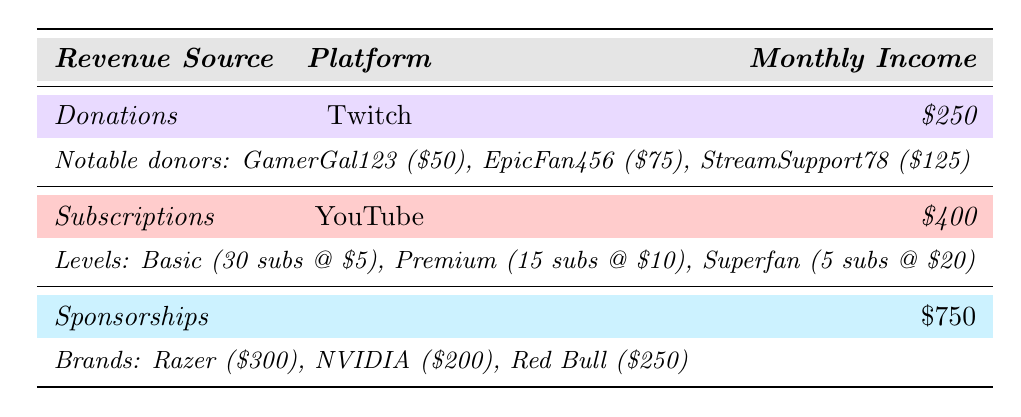What is the total monthly income from donations? The table shows that the average monthly income from donations on Twitch is $250. Thus, the total monthly income from donations is $250.
Answer: $250 How many subscribers are at the Premium level? The table specifies that there are 15 subscribers at the Premium level on YouTube.
Answer: 15 What is the total monthly income from subscriptions? According to the table, the average monthly income from subscriptions on YouTube is $400. Therefore, the total monthly income from subscriptions is $400.
Answer: $400 Which brand brings in the most revenue from sponsorships? The sponsorship section indicates that Razer contributes $300, NVIDIA $200, and Red Bull $250. Thus, Razer brings in the most revenue.
Answer: Razer How much more does the total income from sponsorships exceed the income from donations? The total income from sponsorships is $750 and from donations is $250. To find the difference: $750 - $250 = $500.
Answer: $500 What is the combined income from all three revenue sources? To find the combined income, sum the incomes from donations ($250), subscriptions ($400), and sponsorships ($750): $250 + $400 + $750 = $1400.
Answer: $1400 Are there more subscribers at the Basic level than at the Premium level? The table states there are 30 subscribers at the Basic level and 15 at the Premium level. Since 30 is greater than 15, the answer is yes.
Answer: Yes What is the average subscription price across all levels? The three subscription levels have the following prices: Basic ($5), Premium ($10), Superfan ($20). First, calculate the total price: $5 + $10 + $20 = $35. There are 3 levels, so the average price is $35 / 3 = approximately $11.67.
Answer: $11.67 If all notable donors donated an additional $50 each, what would the new total monthly income from donations be? The current monthly income from donations is $250. If each of the three noted donors (GamerGal123, EpicFan456, StreamSupport78) donates an additional $50, the increase would be $50 * 3 = $150. The new income would be $250 + $150 = $400.
Answer: $400 What percentage of the total income comes from subscriptions? First, calculate the total income of $1400. The income from subscriptions is $400. To find the percentage: ($400 / $1400) * 100 = approximately 28.57%.
Answer: 28.57% 